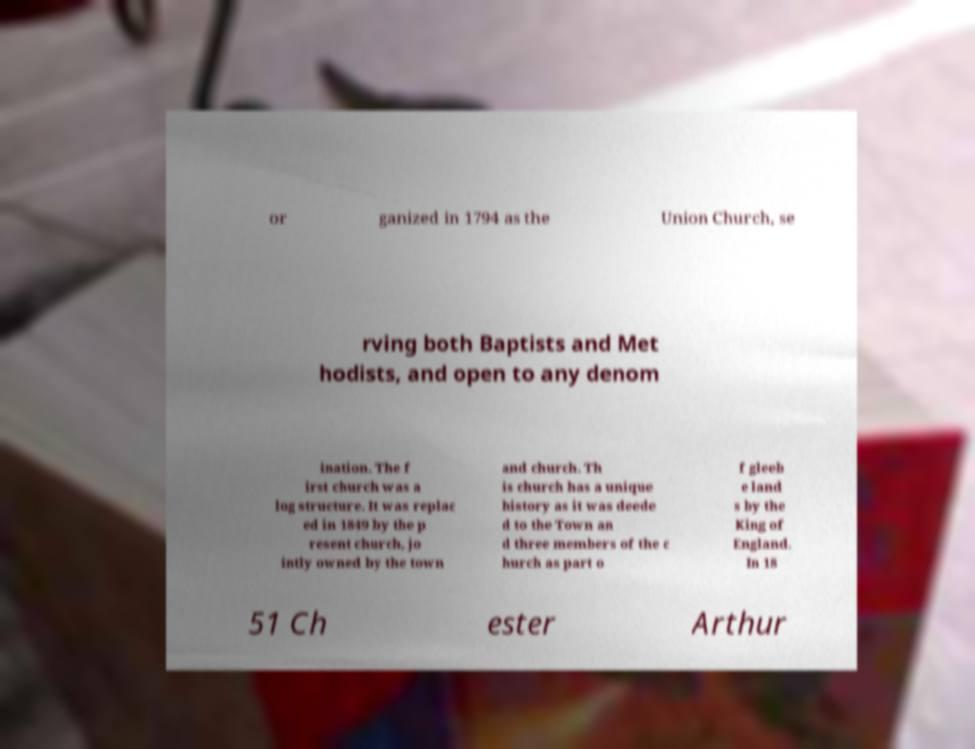I need the written content from this picture converted into text. Can you do that? or ganized in 1794 as the Union Church, se rving both Baptists and Met hodists, and open to any denom ination. The f irst church was a log structure. It was replac ed in 1849 by the p resent church, jo intly owned by the town and church. Th is church has a unique history as it was deede d to the Town an d three members of the c hurch as part o f gleeb e land s by the King of England. In 18 51 Ch ester Arthur 